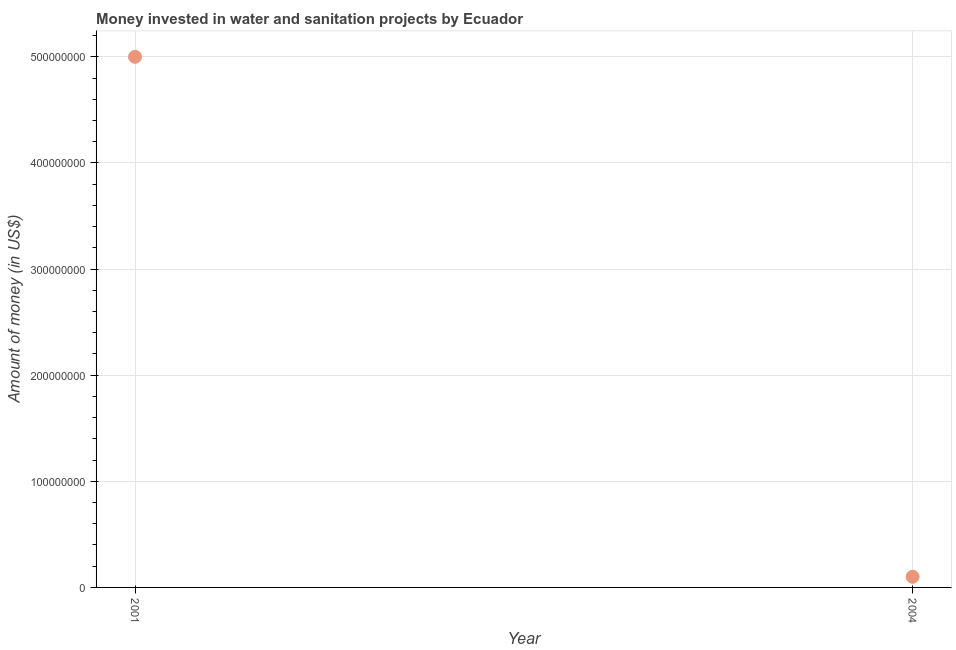What is the investment in 2004?
Keep it short and to the point. 1.00e+07. Across all years, what is the maximum investment?
Ensure brevity in your answer.  5.00e+08. Across all years, what is the minimum investment?
Offer a very short reply. 1.00e+07. In which year was the investment minimum?
Give a very brief answer. 2004. What is the sum of the investment?
Your response must be concise. 5.10e+08. What is the difference between the investment in 2001 and 2004?
Provide a short and direct response. 4.90e+08. What is the average investment per year?
Your answer should be compact. 2.55e+08. What is the median investment?
Your answer should be very brief. 2.55e+08. In how many years, is the investment greater than 480000000 US$?
Provide a short and direct response. 1. Do a majority of the years between 2001 and 2004 (inclusive) have investment greater than 400000000 US$?
Provide a short and direct response. No. What is the ratio of the investment in 2001 to that in 2004?
Offer a very short reply. 50. In how many years, is the investment greater than the average investment taken over all years?
Provide a succinct answer. 1. Does the investment monotonically increase over the years?
Your answer should be compact. No. How many dotlines are there?
Provide a short and direct response. 1. How many years are there in the graph?
Your answer should be very brief. 2. What is the difference between two consecutive major ticks on the Y-axis?
Offer a terse response. 1.00e+08. Are the values on the major ticks of Y-axis written in scientific E-notation?
Provide a short and direct response. No. Does the graph contain grids?
Provide a succinct answer. Yes. What is the title of the graph?
Offer a very short reply. Money invested in water and sanitation projects by Ecuador. What is the label or title of the Y-axis?
Provide a succinct answer. Amount of money (in US$). What is the Amount of money (in US$) in 2001?
Your answer should be very brief. 5.00e+08. What is the Amount of money (in US$) in 2004?
Make the answer very short. 1.00e+07. What is the difference between the Amount of money (in US$) in 2001 and 2004?
Provide a succinct answer. 4.90e+08. 